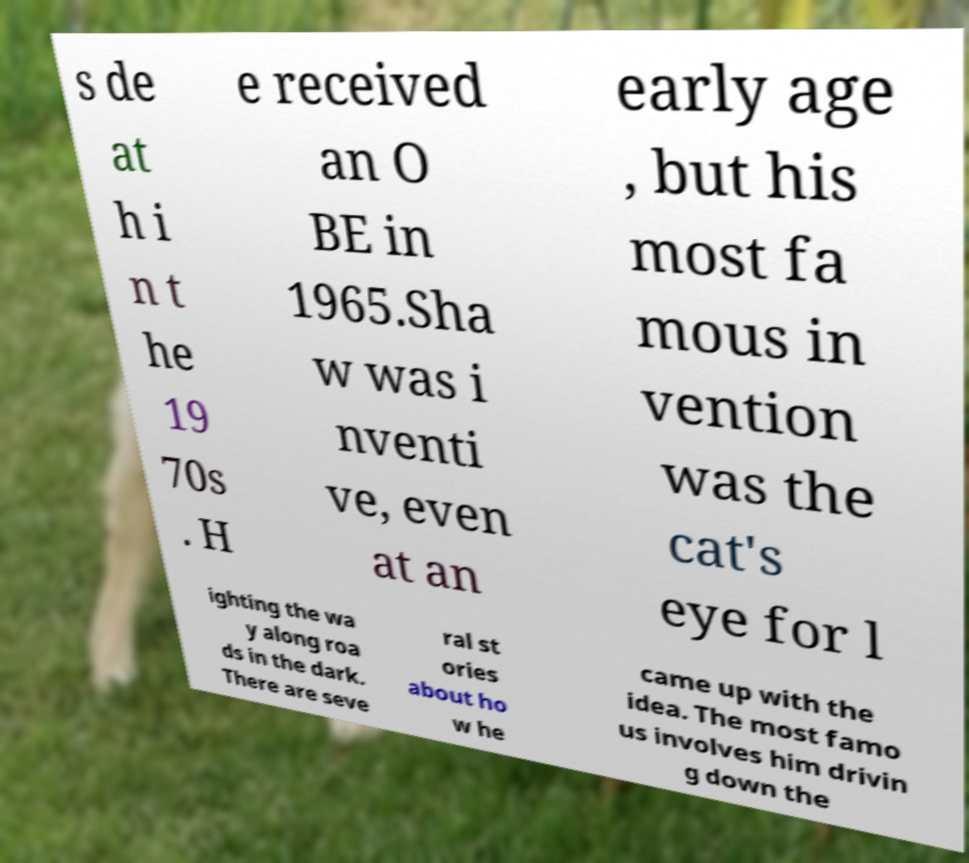Could you extract and type out the text from this image? s de at h i n t he 19 70s . H e received an O BE in 1965.Sha w was i nventi ve, even at an early age , but his most fa mous in vention was the cat's eye for l ighting the wa y along roa ds in the dark. There are seve ral st ories about ho w he came up with the idea. The most famo us involves him drivin g down the 